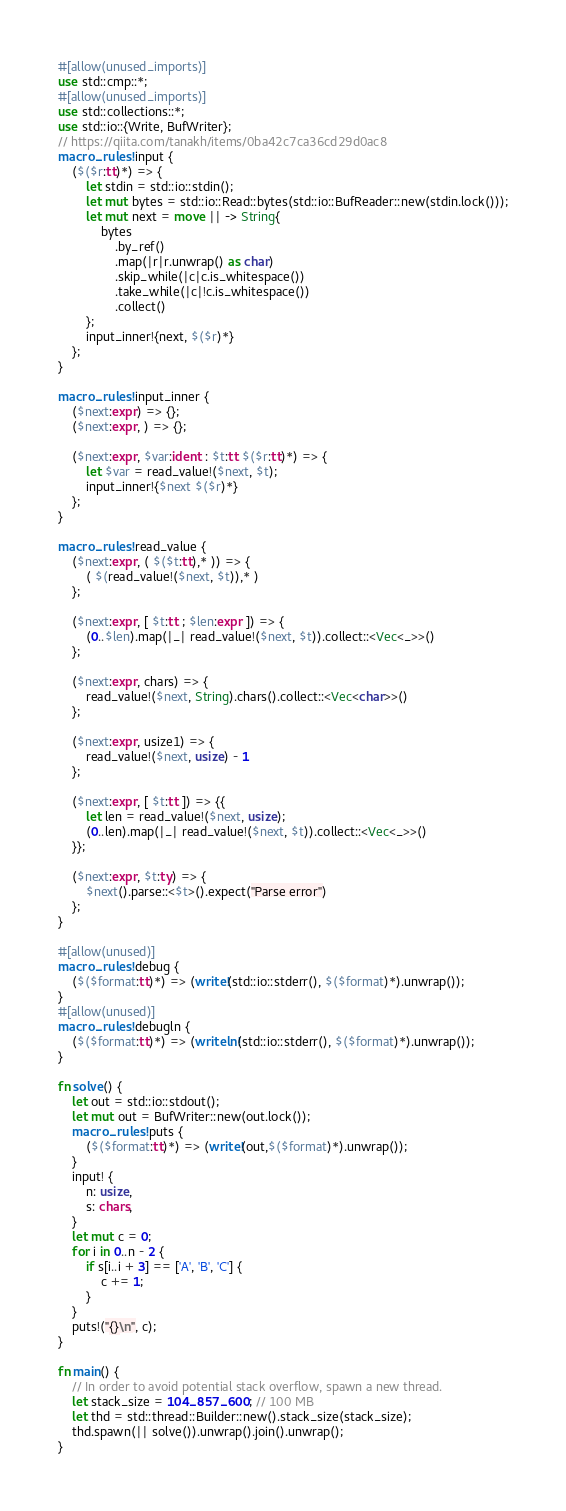Convert code to text. <code><loc_0><loc_0><loc_500><loc_500><_Rust_>#[allow(unused_imports)]
use std::cmp::*;
#[allow(unused_imports)]
use std::collections::*;
use std::io::{Write, BufWriter};
// https://qiita.com/tanakh/items/0ba42c7ca36cd29d0ac8
macro_rules! input {
    ($($r:tt)*) => {
        let stdin = std::io::stdin();
        let mut bytes = std::io::Read::bytes(std::io::BufReader::new(stdin.lock()));
        let mut next = move || -> String{
            bytes
                .by_ref()
                .map(|r|r.unwrap() as char)
                .skip_while(|c|c.is_whitespace())
                .take_while(|c|!c.is_whitespace())
                .collect()
        };
        input_inner!{next, $($r)*}
    };
}

macro_rules! input_inner {
    ($next:expr) => {};
    ($next:expr, ) => {};

    ($next:expr, $var:ident : $t:tt $($r:tt)*) => {
        let $var = read_value!($next, $t);
        input_inner!{$next $($r)*}
    };
}

macro_rules! read_value {
    ($next:expr, ( $($t:tt),* )) => {
        ( $(read_value!($next, $t)),* )
    };

    ($next:expr, [ $t:tt ; $len:expr ]) => {
        (0..$len).map(|_| read_value!($next, $t)).collect::<Vec<_>>()
    };

    ($next:expr, chars) => {
        read_value!($next, String).chars().collect::<Vec<char>>()
    };

    ($next:expr, usize1) => {
        read_value!($next, usize) - 1
    };

    ($next:expr, [ $t:tt ]) => {{
        let len = read_value!($next, usize);
        (0..len).map(|_| read_value!($next, $t)).collect::<Vec<_>>()
    }};

    ($next:expr, $t:ty) => {
        $next().parse::<$t>().expect("Parse error")
    };
}

#[allow(unused)]
macro_rules! debug {
    ($($format:tt)*) => (write!(std::io::stderr(), $($format)*).unwrap());
}
#[allow(unused)]
macro_rules! debugln {
    ($($format:tt)*) => (writeln!(std::io::stderr(), $($format)*).unwrap());
}

fn solve() {
    let out = std::io::stdout();
    let mut out = BufWriter::new(out.lock());
    macro_rules! puts {
        ($($format:tt)*) => (write!(out,$($format)*).unwrap());
    }
    input! {
        n: usize,
        s: chars,
    }
    let mut c = 0;
    for i in 0..n - 2 {
        if s[i..i + 3] == ['A', 'B', 'C'] {
            c += 1;
        }
    }
    puts!("{}\n", c);
}

fn main() {
    // In order to avoid potential stack overflow, spawn a new thread.
    let stack_size = 104_857_600; // 100 MB
    let thd = std::thread::Builder::new().stack_size(stack_size);
    thd.spawn(|| solve()).unwrap().join().unwrap();
}
</code> 